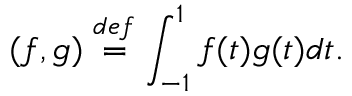Convert formula to latex. <formula><loc_0><loc_0><loc_500><loc_500>( f , g ) \overset { d e f } { = } \int _ { - 1 } ^ { 1 } f ( t ) g ( t ) d t .</formula> 